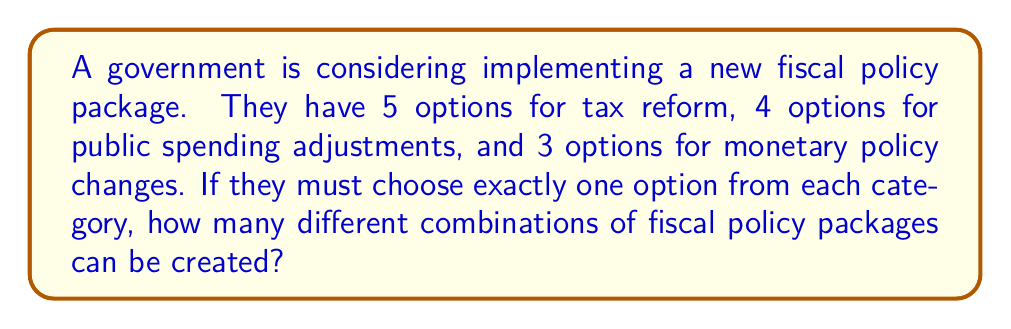Can you solve this math problem? To solve this problem, we'll use the multiplication principle of counting. This principle states that if we have a series of independent choices, the total number of possible outcomes is the product of the number of choices for each decision.

Let's break down the problem:

1. Tax reform options: 5 choices
2. Public spending adjustment options: 4 choices
3. Monetary policy change options: 3 choices

For each policy package, we must choose:
- One option from tax reform (5 choices)
- One option from public spending adjustments (4 choices)
- One option from monetary policy changes (3 choices)

The total number of possible combinations is therefore:

$$ 5 \times 4 \times 3 = 60 $$

This can also be written as:

$$ \text{Total combinations} = \text{Tax options} \times \text{Spending options} \times \text{Monetary options} $$
$$ = 5 \times 4 \times 3 = 60 $$

Thus, there are 60 different possible combinations of fiscal policy packages that can be created given the available options.
Answer: 60 